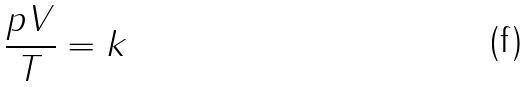<formula> <loc_0><loc_0><loc_500><loc_500>\frac { p V } { T } = k</formula> 